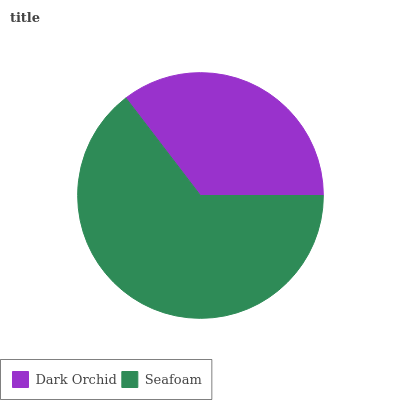Is Dark Orchid the minimum?
Answer yes or no. Yes. Is Seafoam the maximum?
Answer yes or no. Yes. Is Seafoam the minimum?
Answer yes or no. No. Is Seafoam greater than Dark Orchid?
Answer yes or no. Yes. Is Dark Orchid less than Seafoam?
Answer yes or no. Yes. Is Dark Orchid greater than Seafoam?
Answer yes or no. No. Is Seafoam less than Dark Orchid?
Answer yes or no. No. Is Seafoam the high median?
Answer yes or no. Yes. Is Dark Orchid the low median?
Answer yes or no. Yes. Is Dark Orchid the high median?
Answer yes or no. No. Is Seafoam the low median?
Answer yes or no. No. 